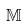Convert formula to latex. <formula><loc_0><loc_0><loc_500><loc_500>\mathbb { M }</formula> 